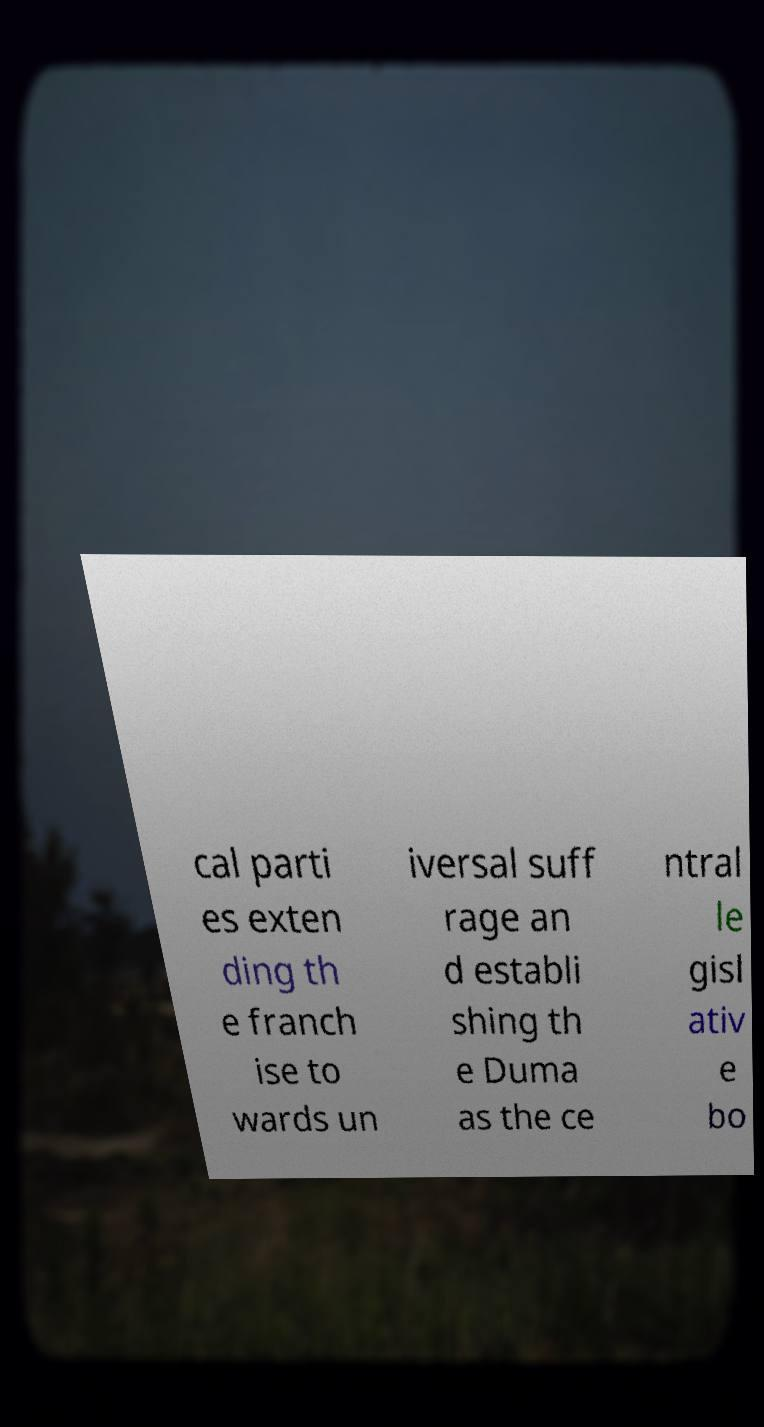Could you assist in decoding the text presented in this image and type it out clearly? cal parti es exten ding th e franch ise to wards un iversal suff rage an d establi shing th e Duma as the ce ntral le gisl ativ e bo 